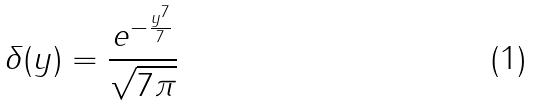Convert formula to latex. <formula><loc_0><loc_0><loc_500><loc_500>\delta ( y ) = \frac { e ^ { - \frac { y ^ { 7 } } { 7 } } } { \sqrt { 7 \pi } }</formula> 